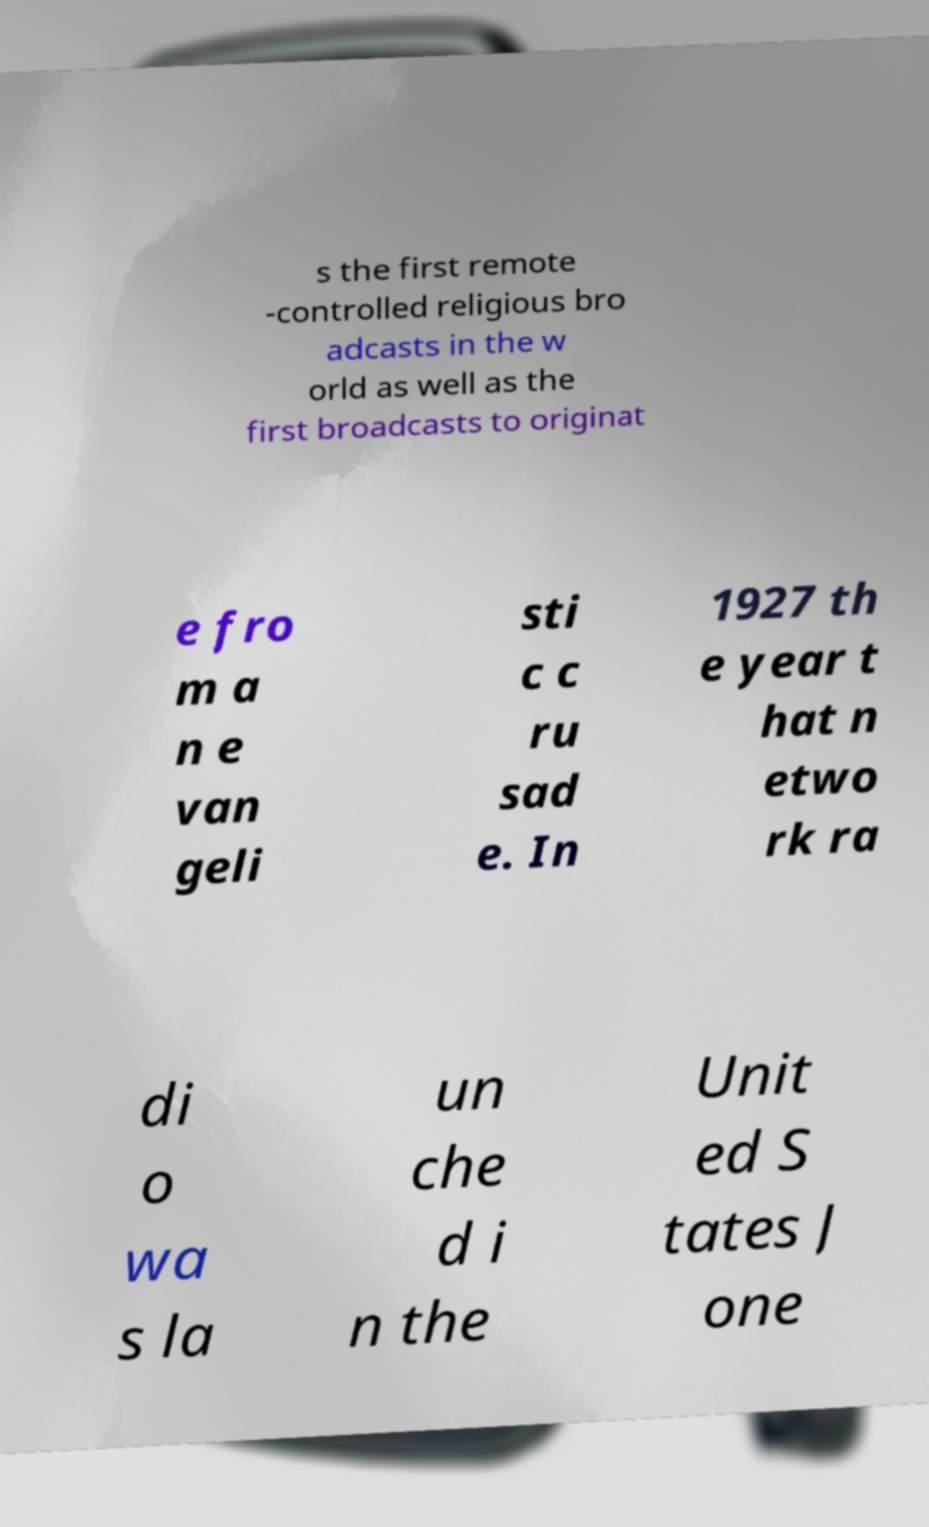For documentation purposes, I need the text within this image transcribed. Could you provide that? s the first remote -controlled religious bro adcasts in the w orld as well as the first broadcasts to originat e fro m a n e van geli sti c c ru sad e. In 1927 th e year t hat n etwo rk ra di o wa s la un che d i n the Unit ed S tates J one 